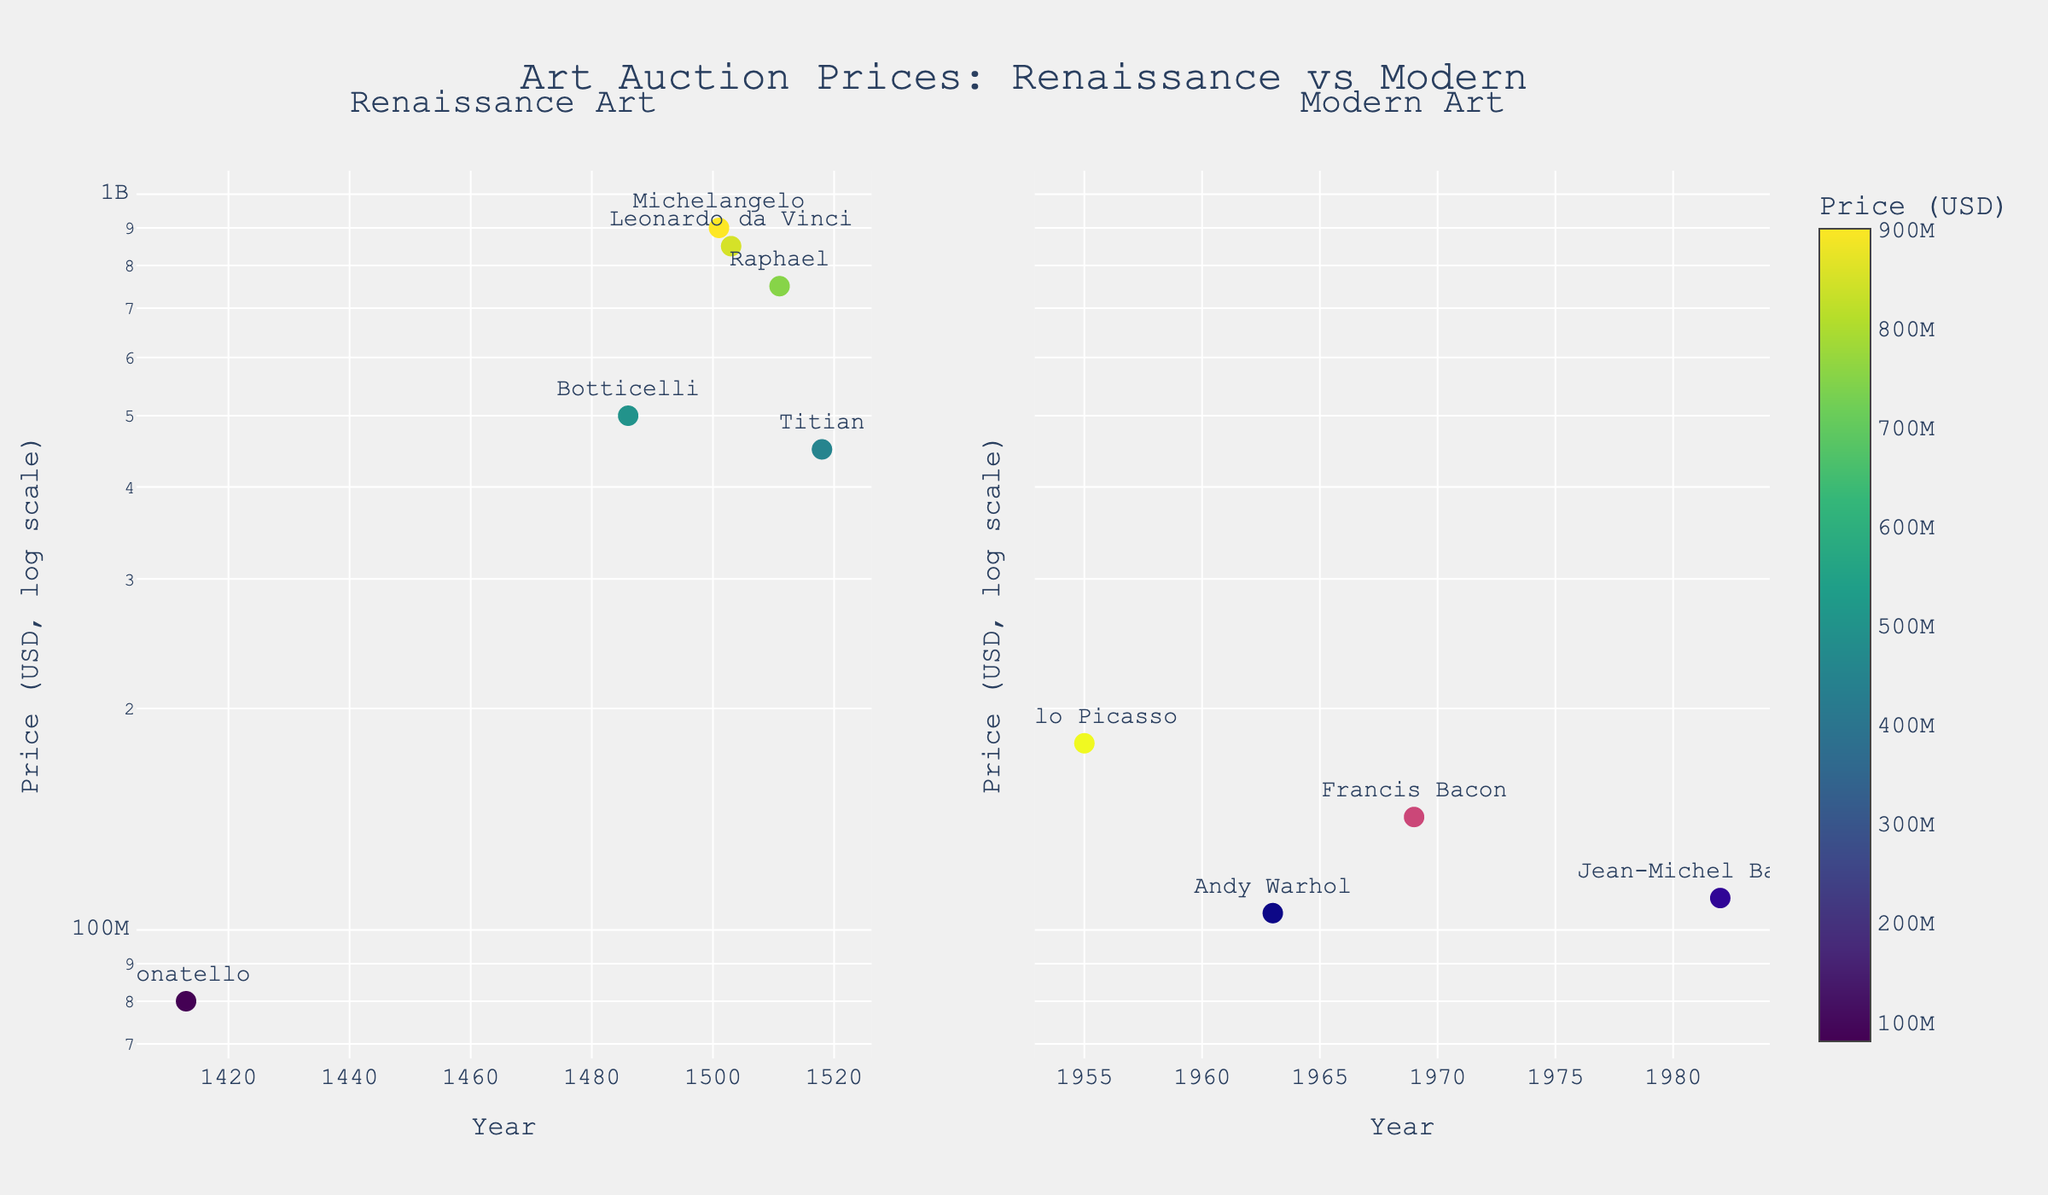How many Renaissance artworks are displayed in the figure? There are 6 data points in the Renaissance subplot representing 6 artworks based on the number of markers.
Answer: 6 What is the price range for Renaissance art in the figure? The highest selling price for Renaissance art is $900,000,000 and the lowest is $80,000,000 as observed from the Y-axis in the log scale subplot.
Answer: $80,000,000 to $900,000,000 Which artist's work had the highest selling price in the Modern Art subplot? The subplot for Modern Art shows that Pablo Picasso's "Les Femmes d'Alger" sold for the highest price, which is around $179,365,000.
Answer: Pablo Picasso What is the average selling price of Renaissance artworks in the figure? Add the prices of all Renaissance artworks: $850,000,000 + $900,000,000 + $750,000,000 + $80,000,000 + $450,000,000 + $500,000,000, then divide by 6. The sum is $3,530,000,000; the average is $3,530,000,000 ÷ 6 = $588,333,333.33.
Answer: $588,333,333.33 Which era shows a more diverse range of selling prices on the log-scale plot? By visually comparing the lengths of the logarithmic scales in both subplots, Renaissance artworks have a more spread-out distribution of prices, ranging from $80,000,000 to $900,000,000, while Modern artworks are more clustered between $100,000,000 and $180,000,000.
Answer: Renaissance How does the selling price of Botticelli's "The Birth of Venus" compare to Titian's "Assumption of the Virgin"? Botticelli's "The Birth of Venus" sold for approximately $500,000,000, while Titian's "Assumption of the Virgin" fetched about $450,000,000, making Botticelli's work more expensive.
Answer: Botticelli's is higher What is the price difference between the most expensive Renaissance art and the most expensive Modern art displayed in the figure? The most expensive Renaissance art is Michelangelo’s “David” at $900,000,000, and for Modern art, Pablo Picasso’s “Les Femmes d'Alger” at $179,365,000. The difference is $900,000,000 - $179,365,000 = $720,635,000.
Answer: $720,635,000 Is there any artist featured in both subplots? Observing the artists, none of the names appear in both the Renaissance and Modern subplots.
Answer: No What year has the oldest artwork in the Modern Art subplot? The oldest artwork in the Modern Art subplot is from the year 1955, "Les Femmes d'Alger" by Pablo Picasso.
Answer: 1955 